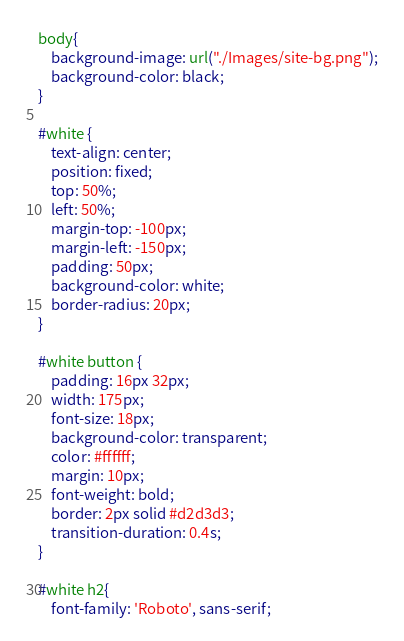Convert code to text. <code><loc_0><loc_0><loc_500><loc_500><_CSS_>body{
	background-image: url("./Images/site-bg.png");
	background-color: black;
}

#white {
	text-align: center;
	position: fixed;
	top: 50%;
	left: 50%;
	margin-top: -100px;
	margin-left: -150px;
	padding: 50px;
	background-color: white;
	border-radius: 20px;
}

#white button {
	padding: 16px 32px;
	width: 175px;
	font-size: 18px;
	background-color: transparent;
	color: #ffffff;
	margin: 10px;
	font-weight: bold;
	border: 2px solid #d2d3d3;
	transition-duration: 0.4s;
}

#white h2{
	font-family: 'Roboto', sans-serif;</code> 